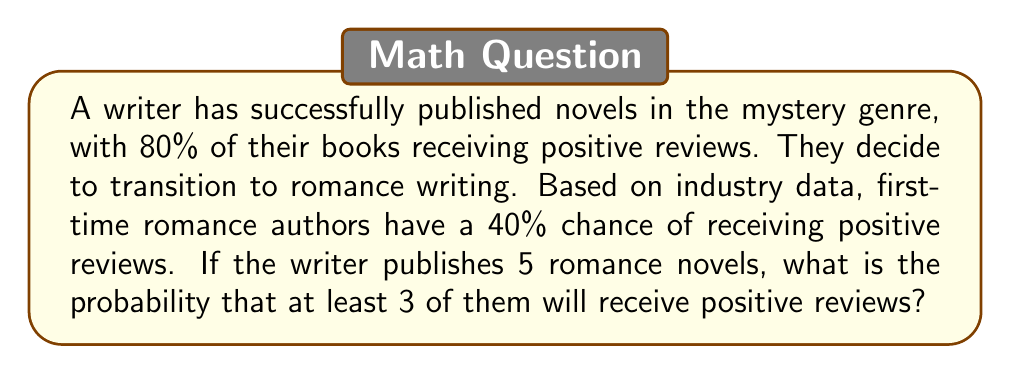Show me your answer to this math problem. To solve this problem, we'll use the binomial probability distribution:

1. Identify the parameters:
   $n = 5$ (number of romance novels)
   $p = 0.4$ (probability of positive review for a new romance author)
   $k \geq 3$ (we want at least 3 positive reviews)

2. Calculate the probability of exactly 3, 4, and 5 positive reviews:

   $P(X = k) = \binom{n}{k} p^k (1-p)^{n-k}$

   For $k = 3$:
   $$P(X = 3) = \binom{5}{3} (0.4)^3 (0.6)^2 = 10 \times 0.064 \times 0.36 = 0.2304$$

   For $k = 4$:
   $$P(X = 4) = \binom{5}{4} (0.4)^4 (0.6)^1 = 5 \times 0.0256 \times 0.6 = 0.0768$$

   For $k = 5$:
   $$P(X = 5) = \binom{5}{5} (0.4)^5 (0.6)^0 = 1 \times 0.01024 \times 1 = 0.01024$$

3. Sum the probabilities for at least 3 positive reviews:
   $$P(X \geq 3) = P(X = 3) + P(X = 4) + P(X = 5)$$
   $$P(X \geq 3) = 0.2304 + 0.0768 + 0.01024 = 0.31744$$

4. Convert to percentage:
   $0.31744 \times 100\% = 31.744\%$
Answer: 31.744% 